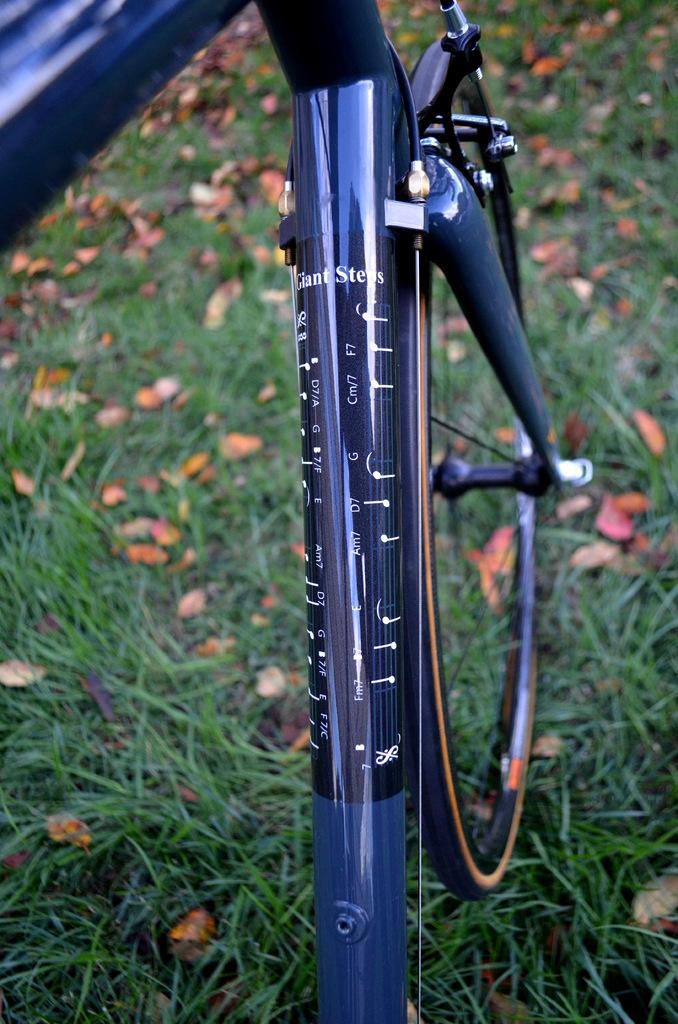What is the main object in the image? There is a bicycle in the image. How is the bicycle depicted in the image? The bicycle appears to be truncated. What type of terrain is visible in the image? There is grass in the image. How many grains of wheat are visible in the image? There are no grains of wheat present in the image. What type of cap is the person wearing in the image? There is no person or cap present in the image. 